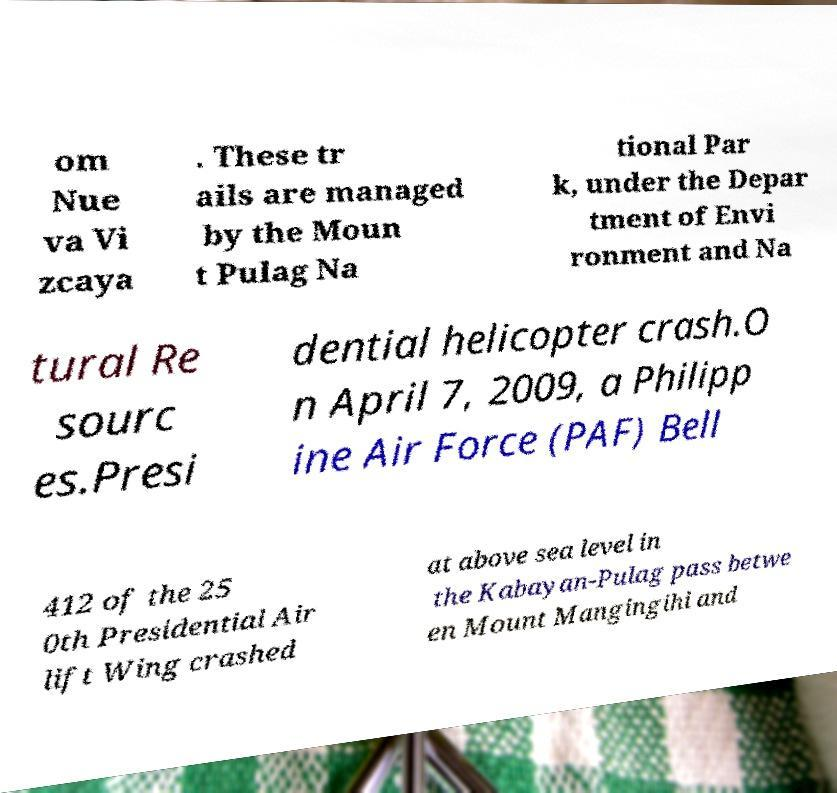What messages or text are displayed in this image? I need them in a readable, typed format. om Nue va Vi zcaya . These tr ails are managed by the Moun t Pulag Na tional Par k, under the Depar tment of Envi ronment and Na tural Re sourc es.Presi dential helicopter crash.O n April 7, 2009, a Philipp ine Air Force (PAF) Bell 412 of the 25 0th Presidential Air lift Wing crashed at above sea level in the Kabayan-Pulag pass betwe en Mount Mangingihi and 